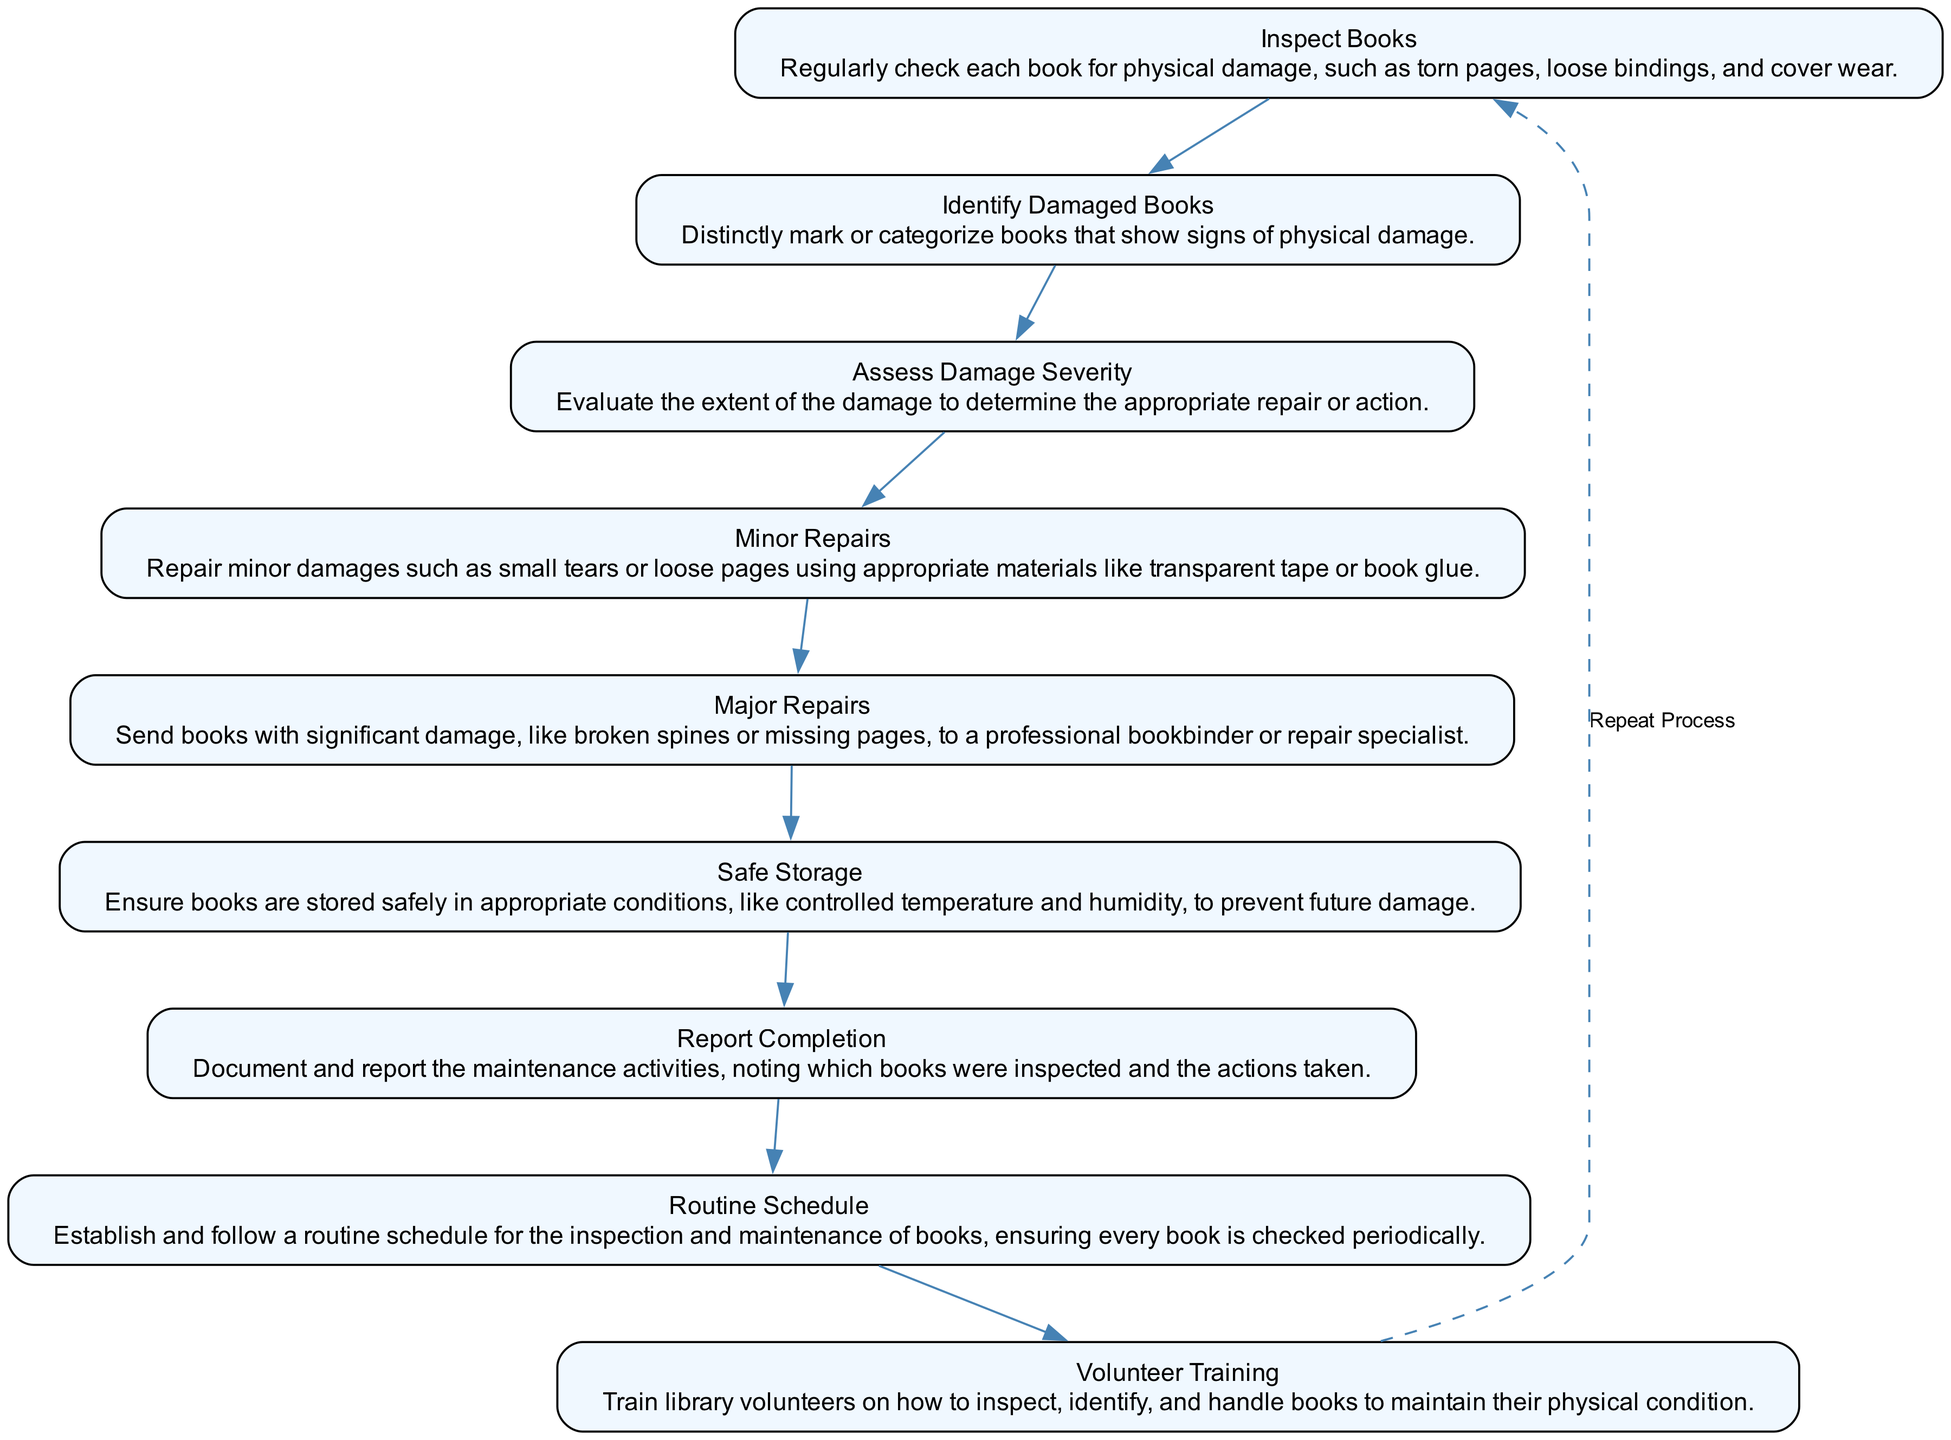What is the first step in the procedure? The first step in the flow chart is labeled "Inspect Books," indicating that the process begins with examining each book for physical damage.
Answer: Inspect Books How many total steps are described in the procedure? By counting the distinct elements in the diagram, there are nine steps outlined in the procedure for maintaining the physical condition of books.
Answer: 9 What action follows "Identify Damaged Books"? The action that follows "Identify Damaged Books" in the diagram is "Assess Damage Severity." This shows the sequence in which the procedure continues after identifying issues.
Answer: Assess Damage Severity Which step involves minor repairs? The step that involves minor repairs is labeled "Minor Repairs," detailing actions taken for small damages like tears or loose pages with specific repair materials.
Answer: Minor Repairs What is the purpose of "Volunteer Training"? "Volunteer Training" aims to teach library volunteers how to properly inspect, identify, and handle books, thus ensuring they maintain the books in good condition.
Answer: Train volunteers Which step should be repeated according to the flowchart? The flowchart indicates that the process from "Inspect Books" to "Report Completion" should be repeated, as denoted by the dashed edge connecting the last step back to the first step.
Answer: Inspect Books What is ensured by "Safe Storage"? "Safe Storage" ensures that books are kept in suitable conditions, such as controlled temperature and humidity, preventing future physical damage to the books.
Answer: Controlled conditions What happens to books with significant damage? Books that have significant damage, such as broken spines, are sent to a professional bookbinder for major repairs as outlined in the "Major Repairs" step.
Answer: Send to professional bookbinder What is documented in "Report Completion"? In the "Report Completion" step, maintenance activities are documented, noting which books were inspected and what actions were taken regarding their condition.
Answer: Document maintenance activities 